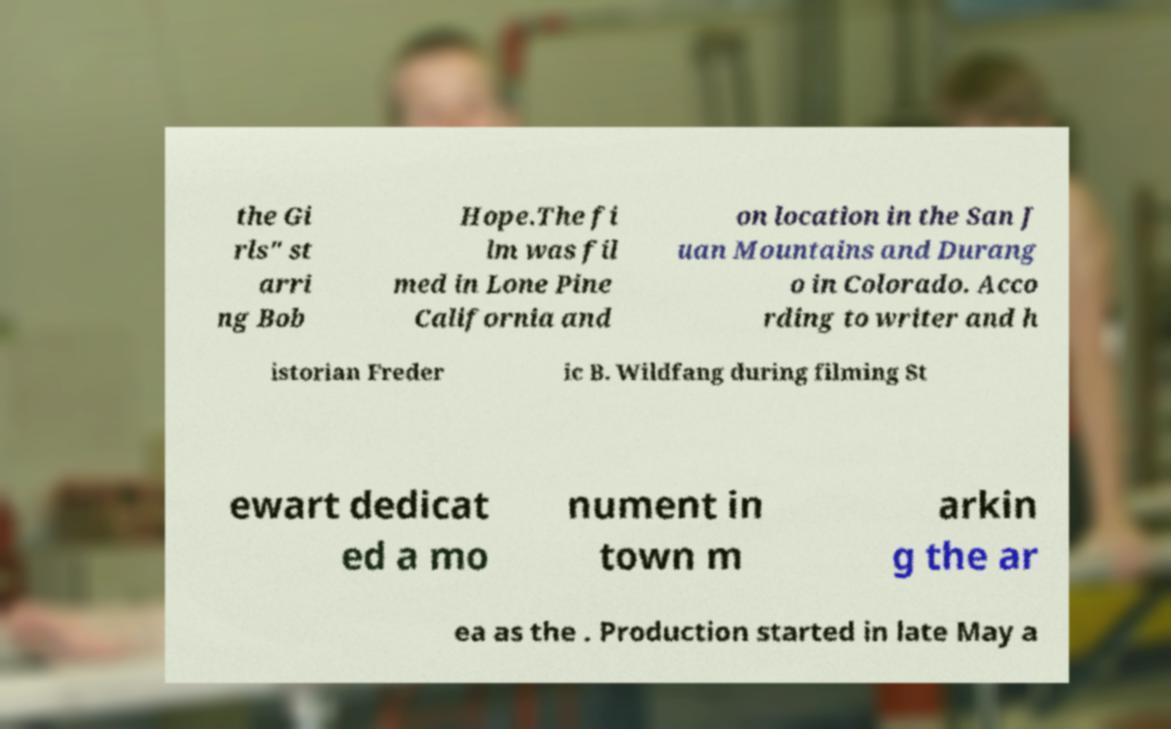Could you assist in decoding the text presented in this image and type it out clearly? the Gi rls" st arri ng Bob Hope.The fi lm was fil med in Lone Pine California and on location in the San J uan Mountains and Durang o in Colorado. Acco rding to writer and h istorian Freder ic B. Wildfang during filming St ewart dedicat ed a mo nument in town m arkin g the ar ea as the . Production started in late May a 